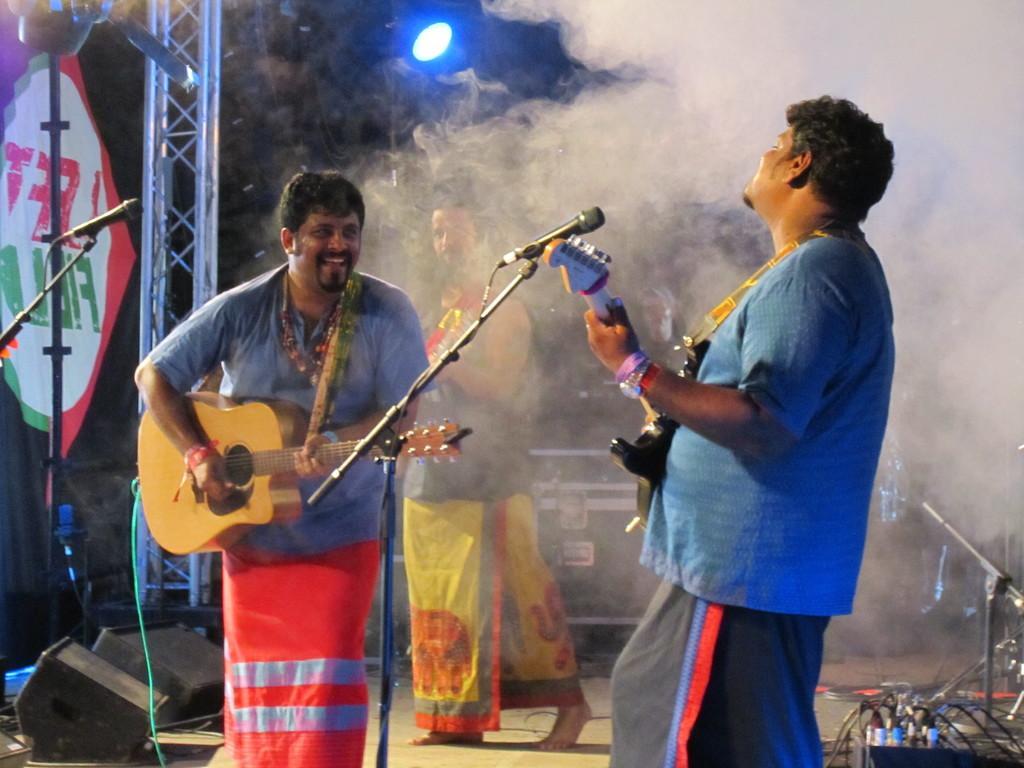Could you give a brief overview of what you see in this image? In this picture, In the right side there is a man standing and holding a microphone and in the left side there is a man standing and holding a music instrument which is in yellow color and in the background there is a man walking and there is a blue color light in the top. 